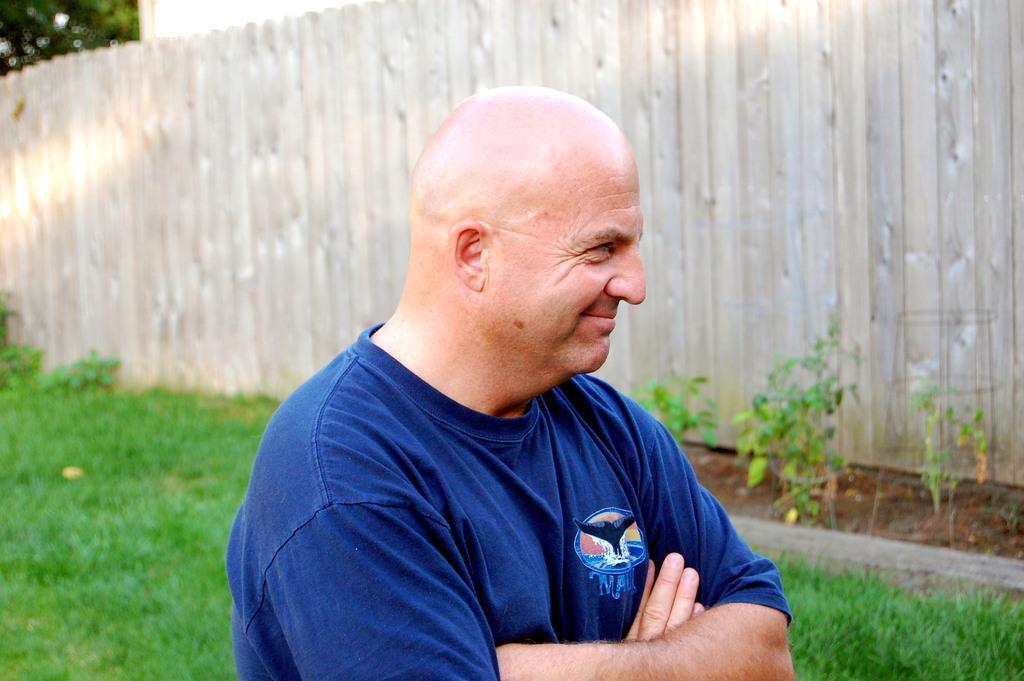Describe this image in one or two sentences. There is a man smiling and wore blue shirt and we can see grass. Background we can see wall and plants. 